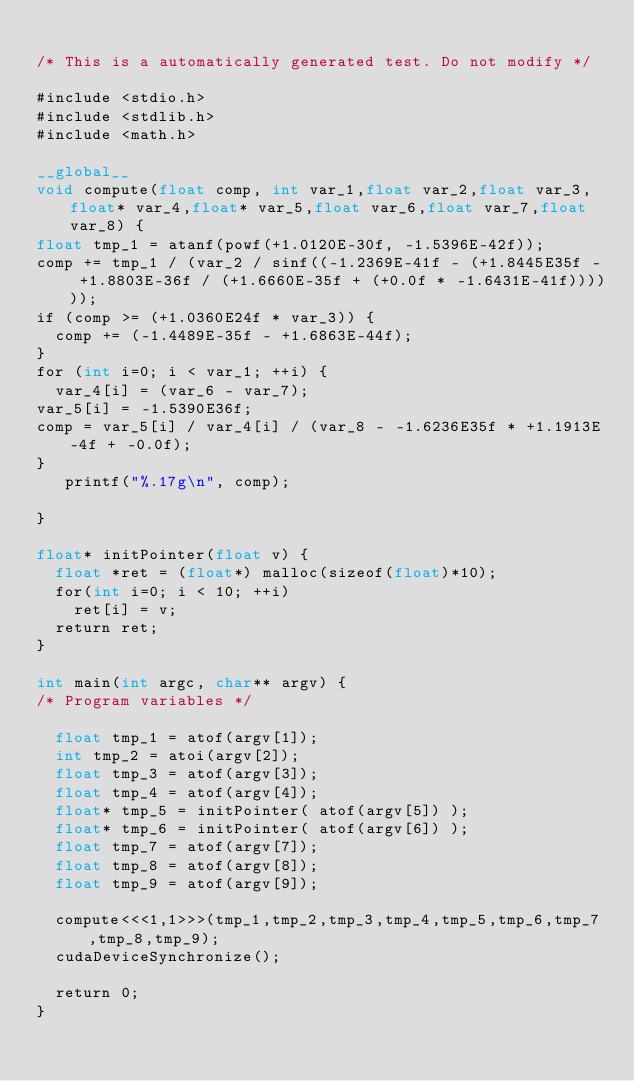<code> <loc_0><loc_0><loc_500><loc_500><_Cuda_>
/* This is a automatically generated test. Do not modify */

#include <stdio.h>
#include <stdlib.h>
#include <math.h>

__global__
void compute(float comp, int var_1,float var_2,float var_3,float* var_4,float* var_5,float var_6,float var_7,float var_8) {
float tmp_1 = atanf(powf(+1.0120E-30f, -1.5396E-42f));
comp += tmp_1 / (var_2 / sinf((-1.2369E-41f - (+1.8445E35f - +1.8803E-36f / (+1.6660E-35f + (+0.0f * -1.6431E-41f))))));
if (comp >= (+1.0360E24f * var_3)) {
  comp += (-1.4489E-35f - +1.6863E-44f);
}
for (int i=0; i < var_1; ++i) {
  var_4[i] = (var_6 - var_7);
var_5[i] = -1.5390E36f;
comp = var_5[i] / var_4[i] / (var_8 - -1.6236E35f * +1.1913E-4f + -0.0f);
}
   printf("%.17g\n", comp);

}

float* initPointer(float v) {
  float *ret = (float*) malloc(sizeof(float)*10);
  for(int i=0; i < 10; ++i)
    ret[i] = v;
  return ret;
}

int main(int argc, char** argv) {
/* Program variables */

  float tmp_1 = atof(argv[1]);
  int tmp_2 = atoi(argv[2]);
  float tmp_3 = atof(argv[3]);
  float tmp_4 = atof(argv[4]);
  float* tmp_5 = initPointer( atof(argv[5]) );
  float* tmp_6 = initPointer( atof(argv[6]) );
  float tmp_7 = atof(argv[7]);
  float tmp_8 = atof(argv[8]);
  float tmp_9 = atof(argv[9]);

  compute<<<1,1>>>(tmp_1,tmp_2,tmp_3,tmp_4,tmp_5,tmp_6,tmp_7,tmp_8,tmp_9);
  cudaDeviceSynchronize();

  return 0;
}
</code> 